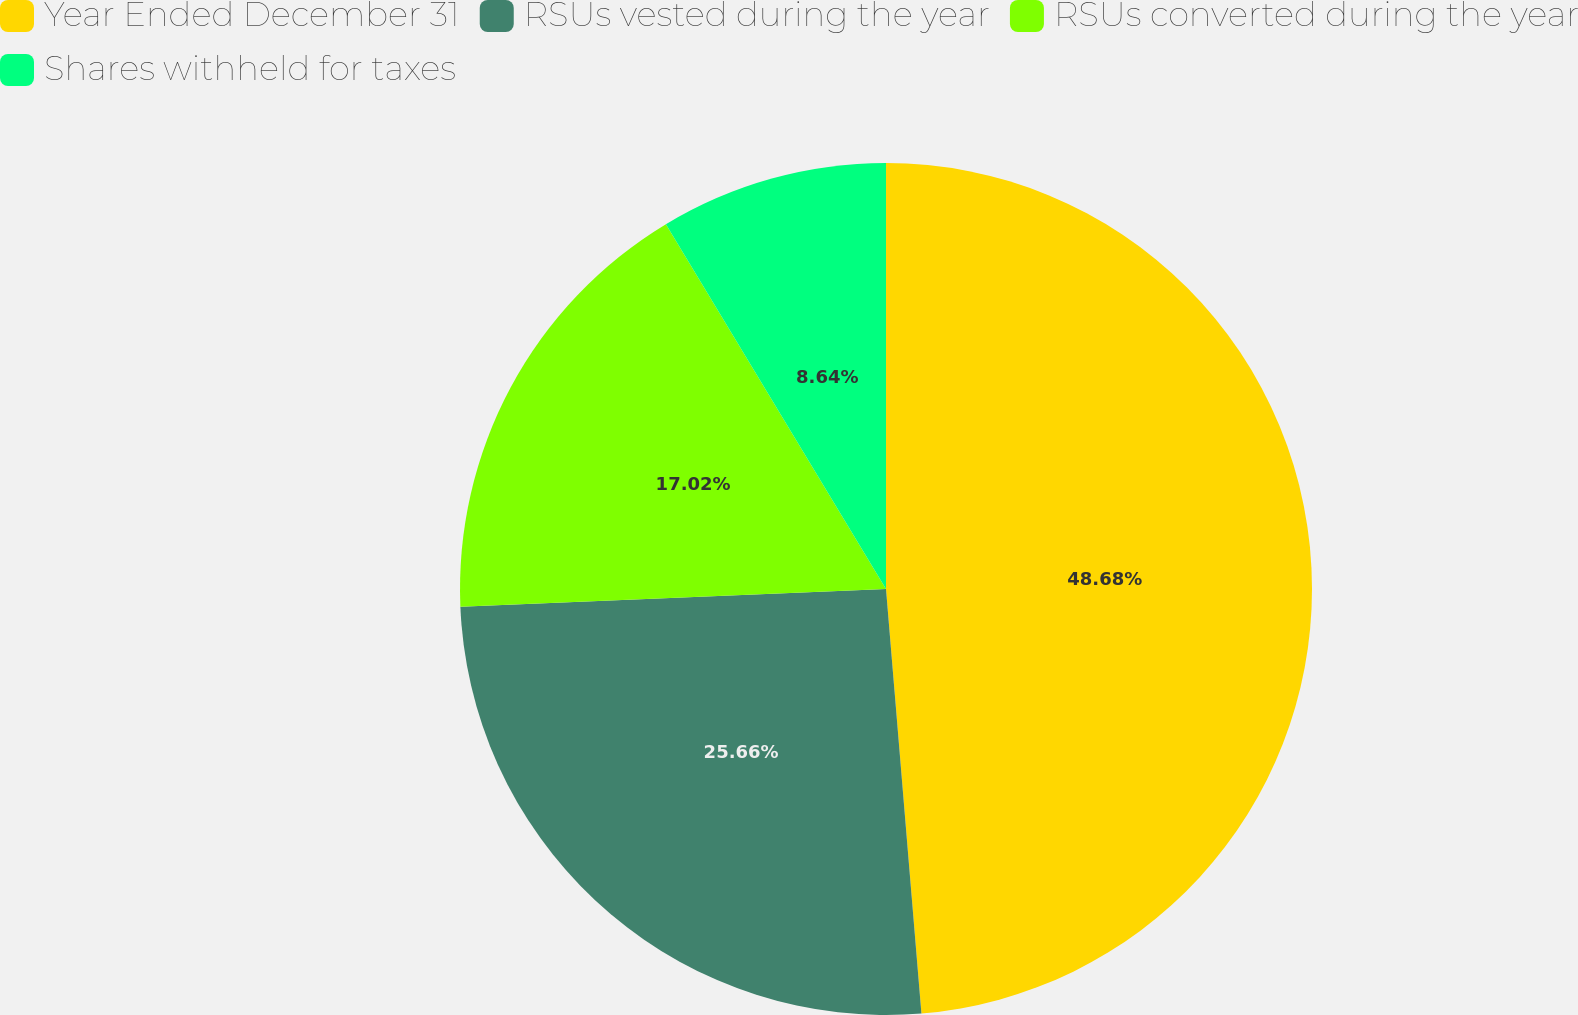Convert chart to OTSL. <chart><loc_0><loc_0><loc_500><loc_500><pie_chart><fcel>Year Ended December 31<fcel>RSUs vested during the year<fcel>RSUs converted during the year<fcel>Shares withheld for taxes<nl><fcel>48.67%<fcel>25.66%<fcel>17.02%<fcel>8.64%<nl></chart> 